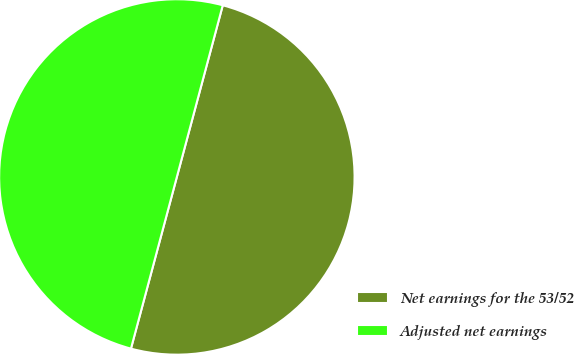Convert chart to OTSL. <chart><loc_0><loc_0><loc_500><loc_500><pie_chart><fcel>Net earnings for the 53/52<fcel>Adjusted net earnings<nl><fcel>50.0%<fcel>50.0%<nl></chart> 